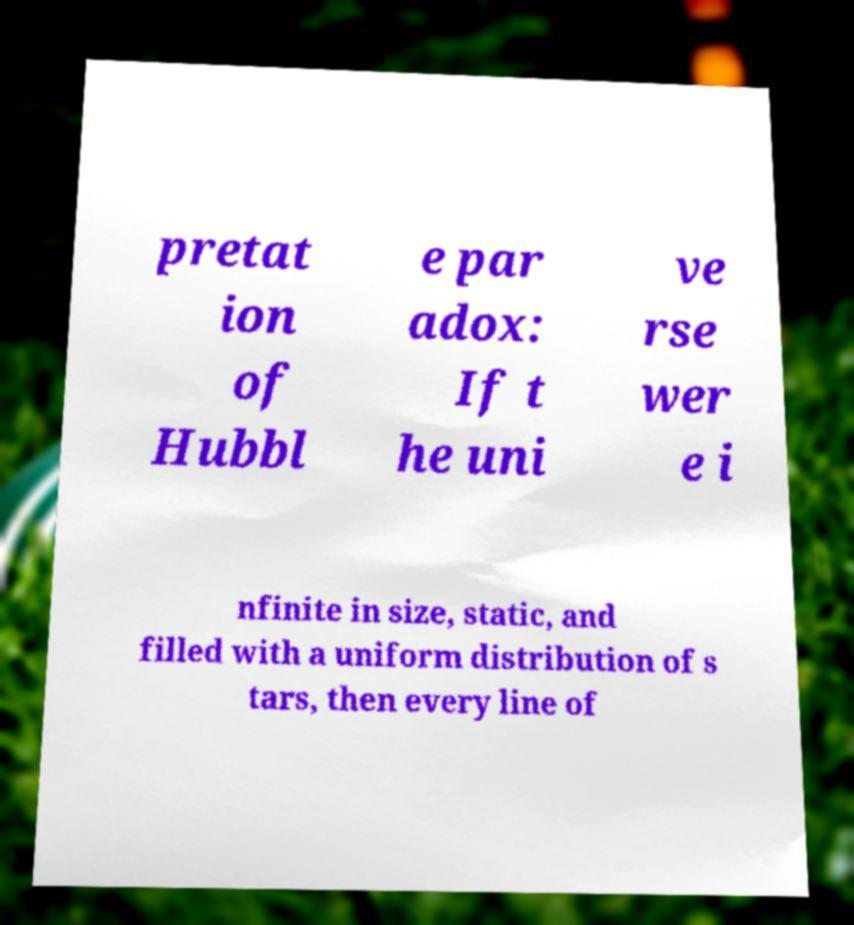Can you accurately transcribe the text from the provided image for me? pretat ion of Hubbl e par adox: If t he uni ve rse wer e i nfinite in size, static, and filled with a uniform distribution of s tars, then every line of 